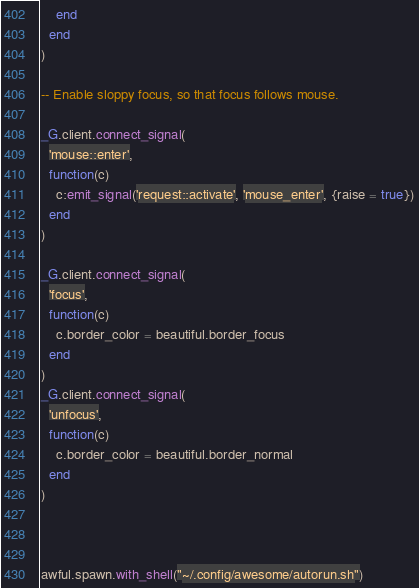<code> <loc_0><loc_0><loc_500><loc_500><_Lua_>    end
  end
)

-- Enable sloppy focus, so that focus follows mouse.

_G.client.connect_signal(
  'mouse::enter',
  function(c)
    c:emit_signal('request::activate', 'mouse_enter', {raise = true})
  end
)

_G.client.connect_signal(
  'focus',
  function(c)
    c.border_color = beautiful.border_focus
  end
)
_G.client.connect_signal(
  'unfocus',
  function(c)
    c.border_color = beautiful.border_normal
  end
)



awful.spawn.with_shell("~/.config/awesome/autorun.sh")
</code> 